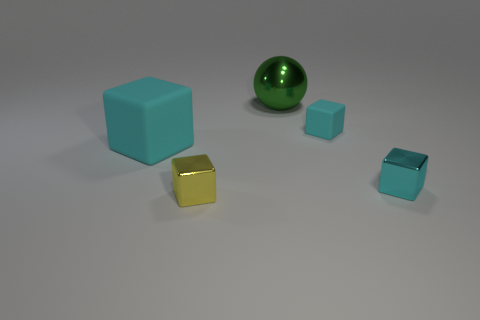Subtract all tiny blocks. How many blocks are left? 1 Add 5 big cyan rubber objects. How many objects exist? 10 Subtract all spheres. How many objects are left? 4 Subtract all yellow cubes. How many cubes are left? 3 Add 5 large cyan rubber things. How many large cyan rubber things are left? 6 Add 5 purple shiny blocks. How many purple shiny blocks exist? 5 Subtract 0 blue spheres. How many objects are left? 5 Subtract 1 blocks. How many blocks are left? 3 Subtract all blue cubes. Subtract all cyan spheres. How many cubes are left? 4 Subtract all green blocks. How many cyan balls are left? 0 